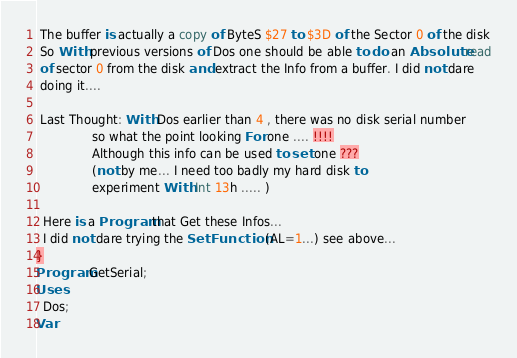Convert code to text. <code><loc_0><loc_0><loc_500><loc_500><_Pascal_> The buffer is actually a copy of ByteS $27 to $3D of the Sector 0 of the disk
 So With previous versions of Dos one should be able to do an Absolute read
 of sector 0 from the disk and extract the Info from a buffer. I did not dare
 doing it....

 Last Thought: With Dos earlier than 4 , there was no disk serial number
               so what the point looking For one .... !!!!
               Although this info can be used to set one ???
               (not by me... I need too badly my hard disk to
               experiment With Int 13h ..... )

  Here is a Program that Get these Infos...
  I did not dare trying the Set Function (AL=1...) see above...
}
Program GetSerial;
Uses
  Dos;
Var</code> 